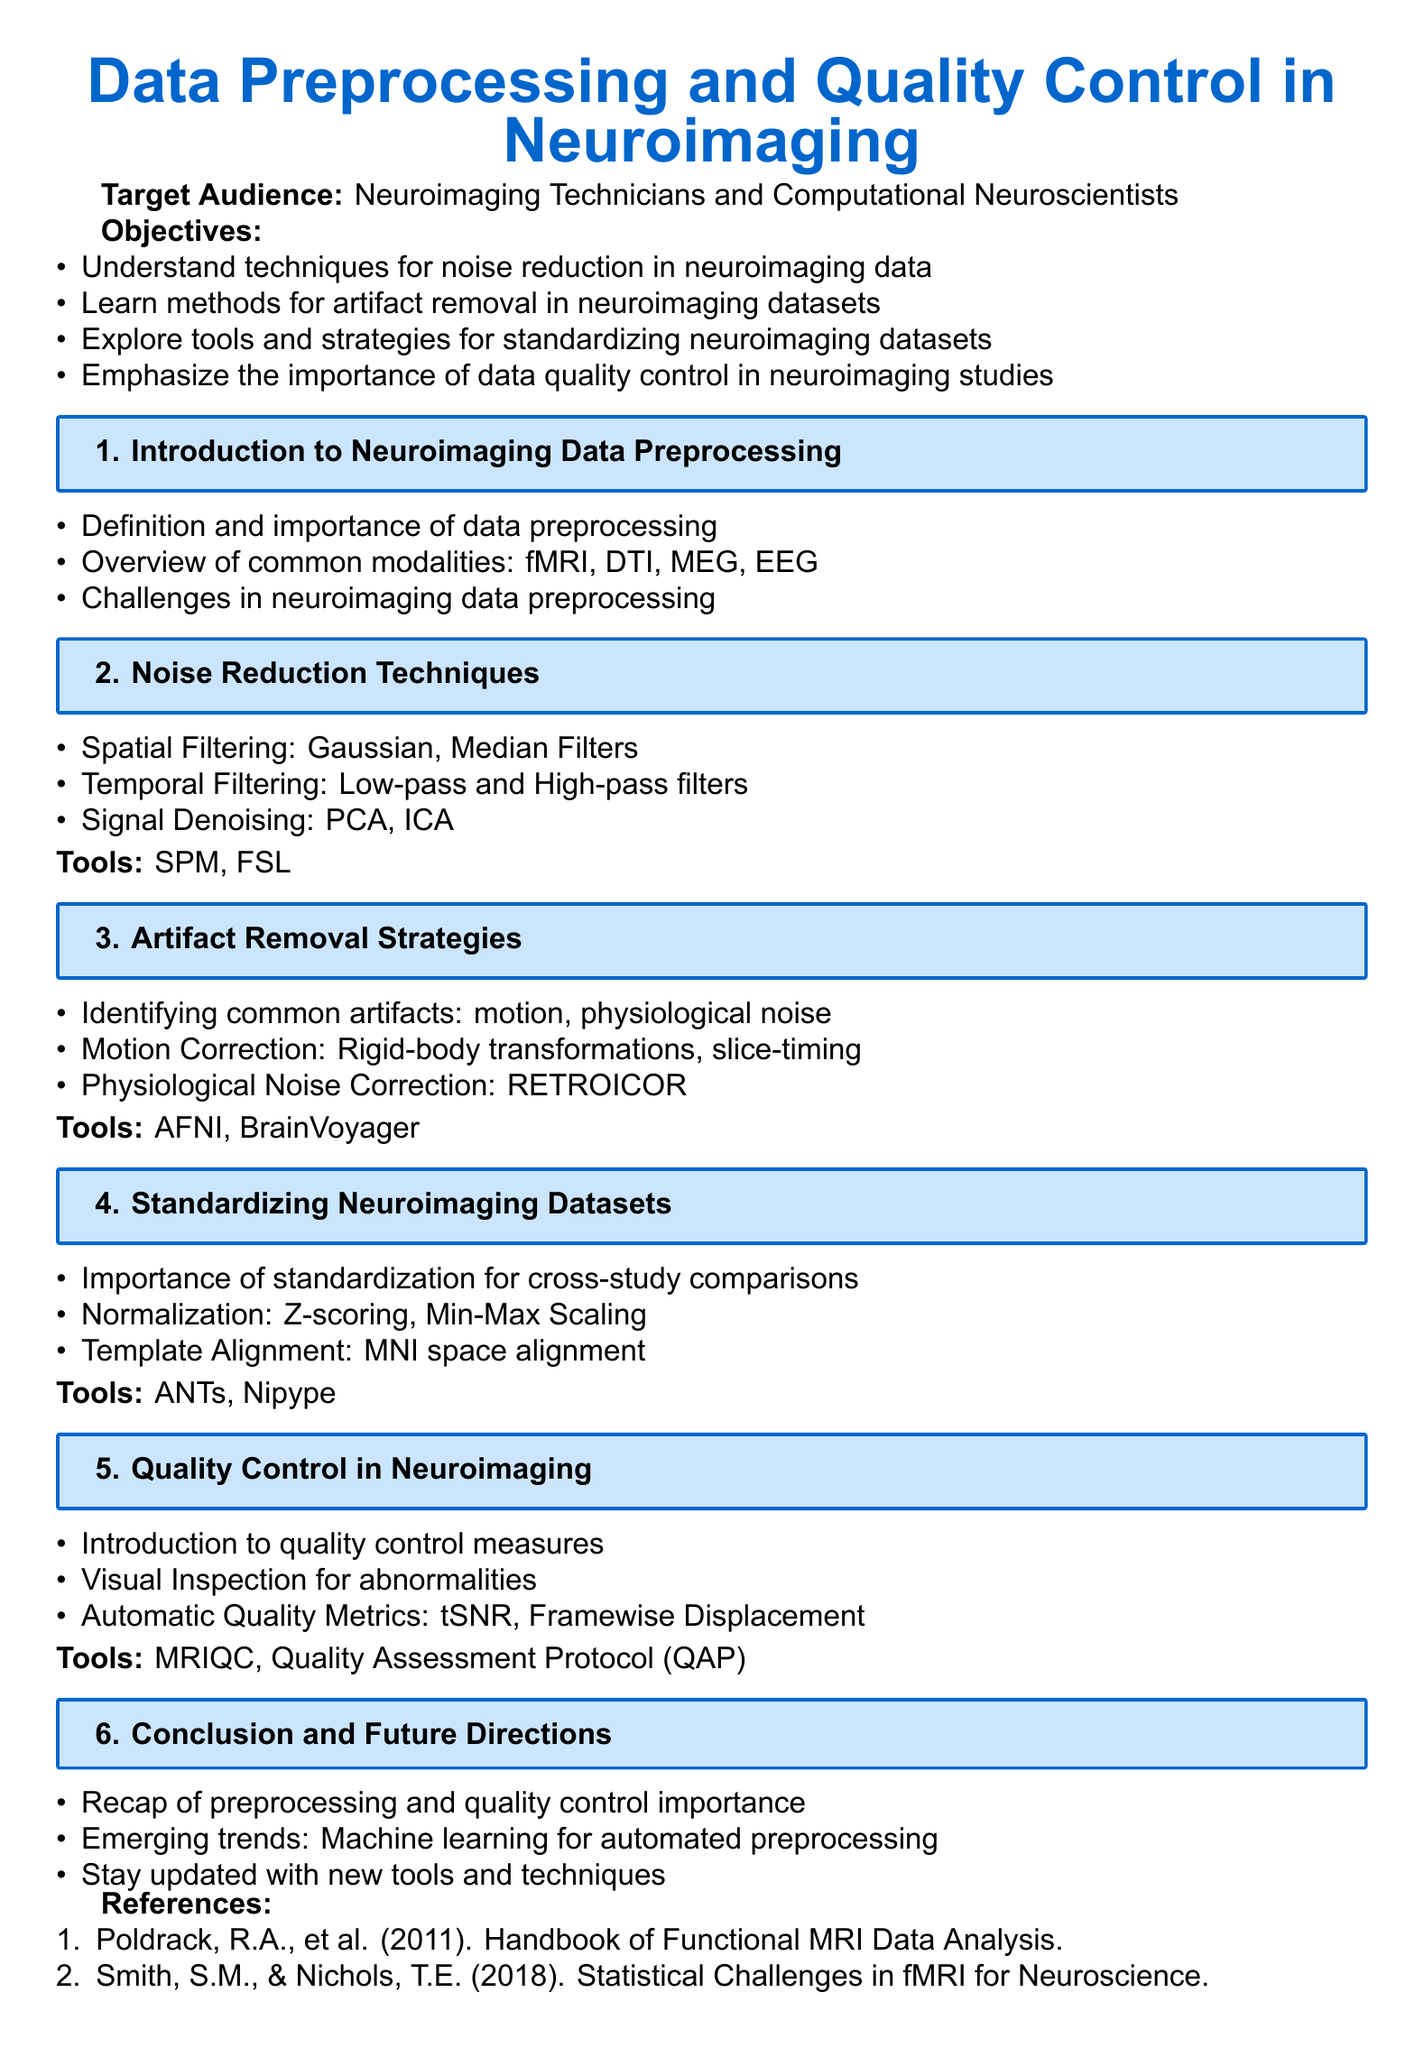What is the title of the lesson plan? The title is found at the beginning of the document and summarizes the main topic, which is the focus on preprocessing and quality control in neuroimaging.
Answer: Data Preprocessing and Quality Control in Neuroimaging Who is the target audience for the lesson plan? The audience is specifically mentioned to clarify who should benefit from the content of the document.
Answer: Neuroimaging Technicians and Computational Neuroscientists What filtration technique is used for noise reduction? The document lists several techniques used for noise reduction, one of which is spatial filtering.
Answer: Gaussian What strategy is emphasized for handling motion artifacts? Describing methods related to motion artifacts, the document highlights a specific correction technique.
Answer: Rigid-body transformations Which tool is suggested for artifact removal? The lesson plan provides names of tools associated with different processing tasks; one is specifically linked with artifact removal.
Answer: AFNI What is the importance of standardization mentioned in the document? The lesson plan outlines reasons for standardizing datasets, particularly in relation to comparisons across different studies.
Answer: Cross-study comparisons What are the automatic quality metrics mentioned? The document gives examples of quality control measures, including specific metrics for assessing data integrity.
Answer: tSNR, Framewise Displacement Which emerging trend is discussed regarding future directions in neuroimaging? The lesson plan touches on advancements likely to impact neuroimaging practices in the future.
Answer: Machine learning for automated preprocessing 